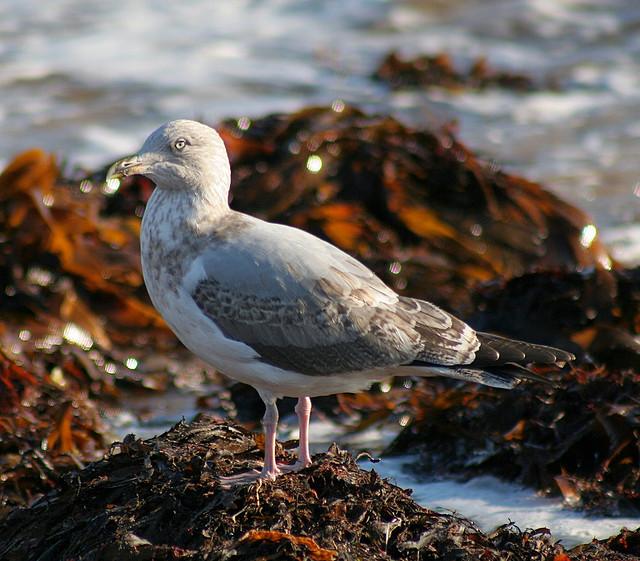Is this bird's head clearly in focus?
Give a very brief answer. Yes. What breed of bird is this?
Give a very brief answer. Seagull. Does the bird have something in it's mouth?
Short answer required. No. What kind of bird is this?
Quick response, please. Seagull. What is the bird sitting on?
Quick response, please. Dirt. 